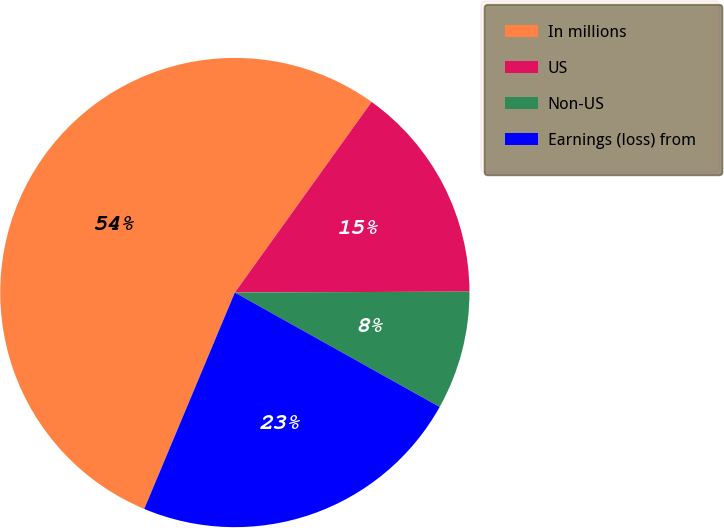Convert chart to OTSL. <chart><loc_0><loc_0><loc_500><loc_500><pie_chart><fcel>In millions<fcel>US<fcel>Non-US<fcel>Earnings (loss) from<nl><fcel>53.59%<fcel>15.03%<fcel>8.17%<fcel>23.2%<nl></chart> 